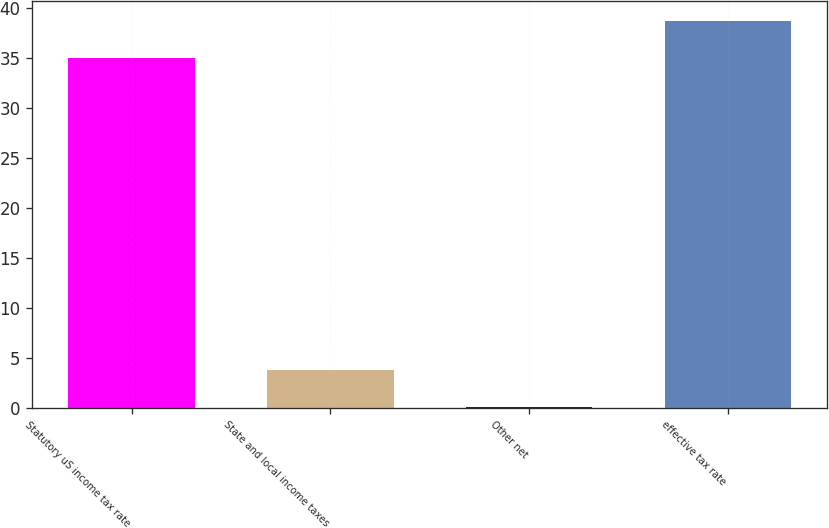Convert chart. <chart><loc_0><loc_0><loc_500><loc_500><bar_chart><fcel>Statutory uS income tax rate<fcel>State and local income taxes<fcel>Other net<fcel>effective tax rate<nl><fcel>35<fcel>3.84<fcel>0.1<fcel>38.74<nl></chart> 